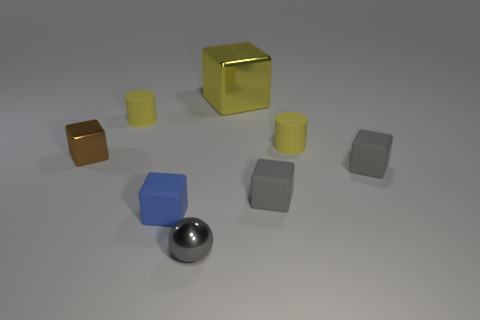Subtract all brown balls. How many gray blocks are left? 2 Subtract all small gray rubber cubes. How many cubes are left? 3 Subtract all brown cubes. How many cubes are left? 4 Add 1 big yellow things. How many objects exist? 9 Subtract all purple blocks. Subtract all yellow spheres. How many blocks are left? 5 Subtract all cubes. How many objects are left? 3 Subtract all spheres. Subtract all yellow metallic cubes. How many objects are left? 6 Add 6 blue matte things. How many blue matte things are left? 7 Add 1 big gray cubes. How many big gray cubes exist? 1 Subtract 0 red balls. How many objects are left? 8 